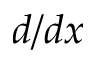<formula> <loc_0><loc_0><loc_500><loc_500>d / d x</formula> 